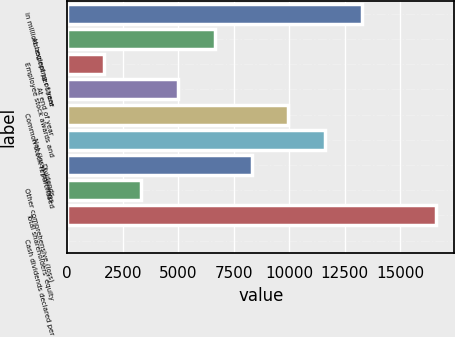Convert chart to OTSL. <chart><loc_0><loc_0><loc_500><loc_500><bar_chart><fcel>in millions except per share<fcel>At beginning of year<fcel>Employee stock awards and<fcel>At end of year<fcel>Common stock repurchased<fcel>Net (loss) earnings<fcel>Dividends<fcel>Other comprehensive (loss)<fcel>Total shareholders' equity<fcel>Cash dividends declared per<nl><fcel>13292.2<fcel>6646.68<fcel>1662.54<fcel>4985.3<fcel>9969.44<fcel>11630.8<fcel>8308.06<fcel>3323.92<fcel>16615<fcel>1.16<nl></chart> 